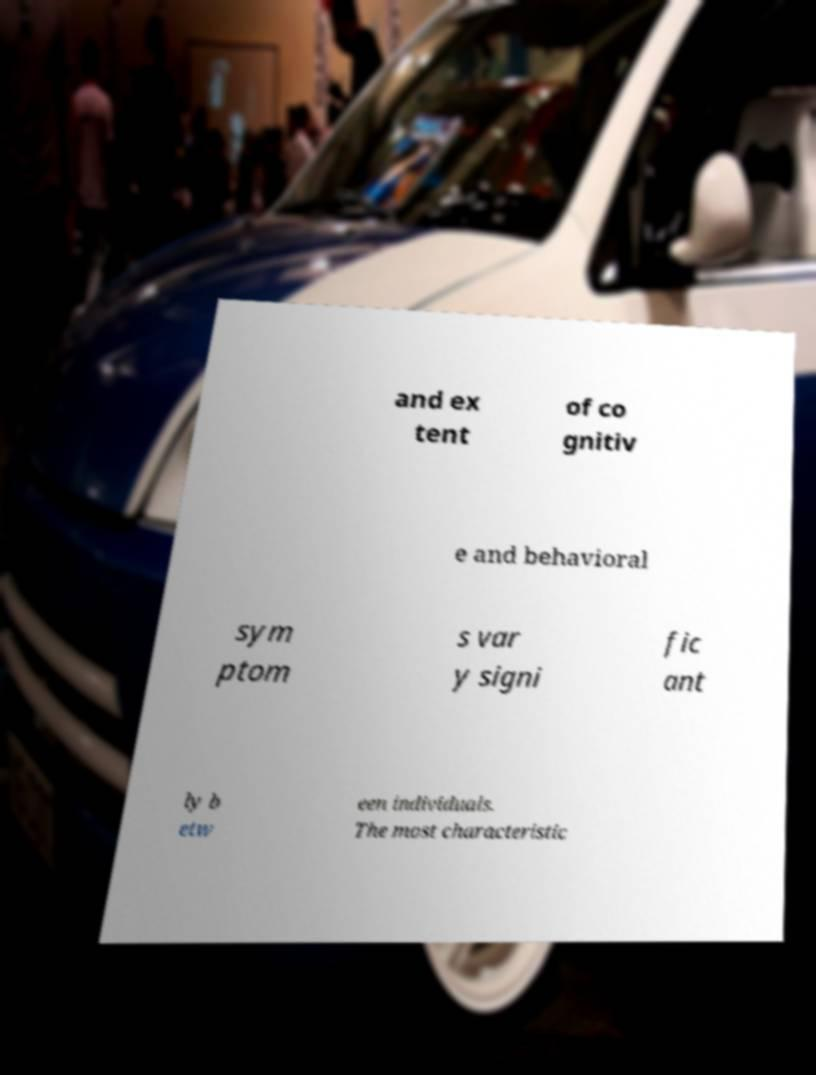Can you read and provide the text displayed in the image?This photo seems to have some interesting text. Can you extract and type it out for me? and ex tent of co gnitiv e and behavioral sym ptom s var y signi fic ant ly b etw een individuals. The most characteristic 